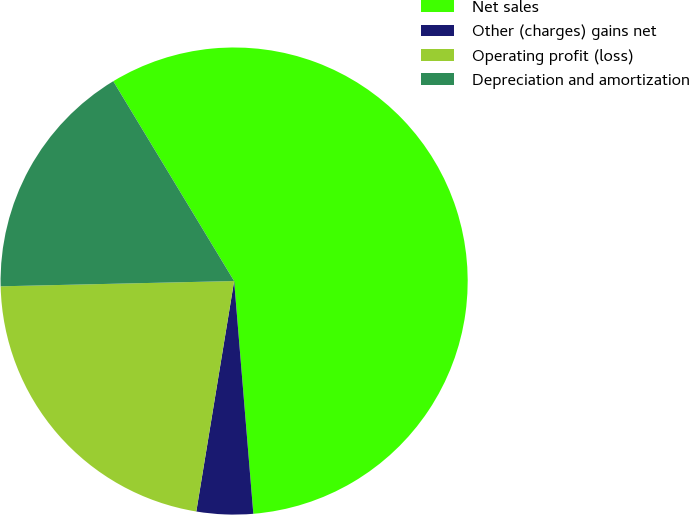<chart> <loc_0><loc_0><loc_500><loc_500><pie_chart><fcel>Net sales<fcel>Other (charges) gains net<fcel>Operating profit (loss)<fcel>Depreciation and amortization<nl><fcel>57.35%<fcel>3.9%<fcel>22.05%<fcel>16.7%<nl></chart> 